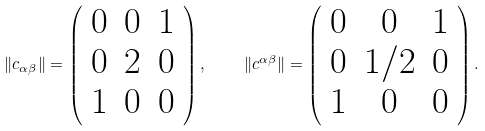Convert formula to latex. <formula><loc_0><loc_0><loc_500><loc_500>\| c _ { \alpha \beta } \| = \left ( \begin{array} { c c c } 0 & 0 & 1 \\ 0 & 2 & 0 \\ 1 & 0 & 0 \end{array} \right ) , \quad \| c ^ { \alpha \beta } \| = \left ( \begin{array} { c c c } 0 & 0 & 1 \\ 0 & 1 / 2 & 0 \\ 1 & 0 & 0 \end{array} \right ) .</formula> 